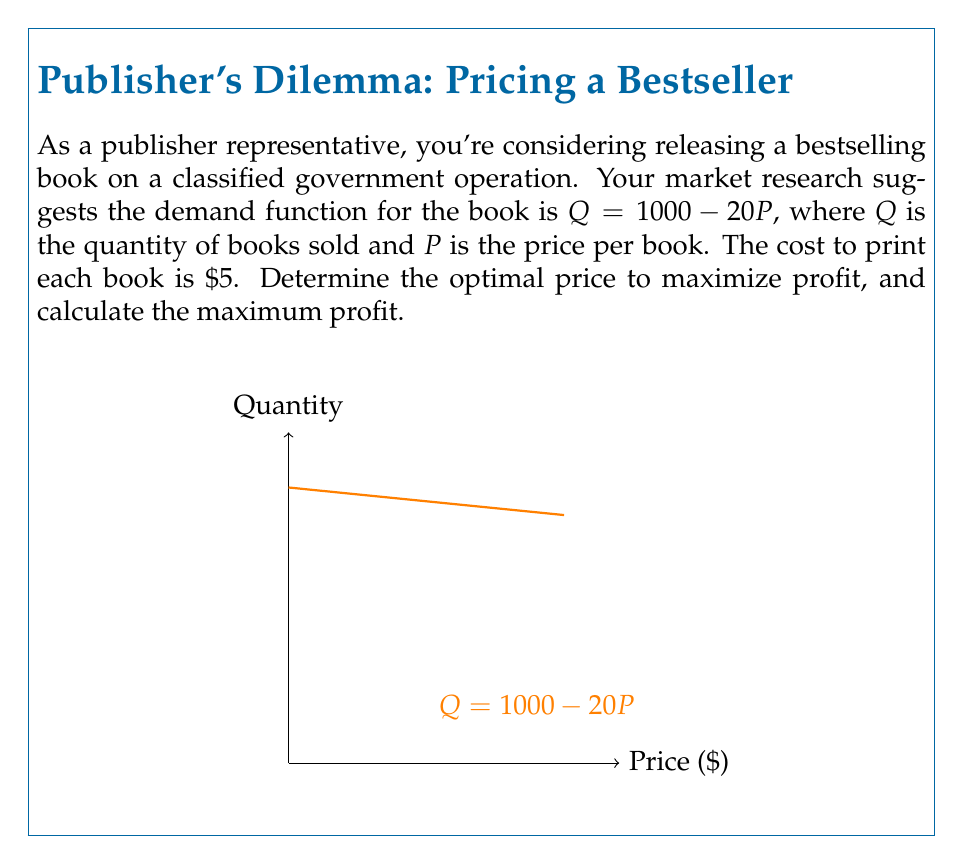Solve this math problem. Let's approach this step-by-step:

1) First, we need to formulate the profit function. Profit is revenue minus cost.
   
   Profit = Revenue - Cost
   $\pi = PQ - 5Q$  (where 5 is the cost per book)

2) Substitute the demand function $Q = 1000 - 20P$ into the profit function:
   
   $\pi = P(1000 - 20P) - 5(1000 - 20P)$

3) Expand this equation:
   
   $\pi = 1000P - 20P^2 - 5000 + 100P$
   $\pi = 1100P - 20P^2 - 5000$

4) To find the maximum profit, we need to find where the derivative of the profit function equals zero:

   $\frac{d\pi}{dP} = 1100 - 40P$

5) Set this equal to zero and solve for P:

   $1100 - 40P = 0$
   $40P = 1100$
   $P = 27.5$

6) To confirm this is a maximum (not a minimum), check the second derivative:

   $\frac{d^2\pi}{dP^2} = -40$

   Since this is negative, we confirm that $P = 27.5$ gives a maximum.

7) Calculate the maximum profit by plugging $P = 27.5$ back into the profit function:

   $\pi = 1100(27.5) - 20(27.5)^2 - 5000$
   $\pi = 30250 - 15125 - 5000 = 10125$

Therefore, the optimal price is $\$27.50$ per book, and the maximum profit is $\$10,125$.
Answer: Optimal price: $\$27.50$; Maximum profit: $\$10,125$ 